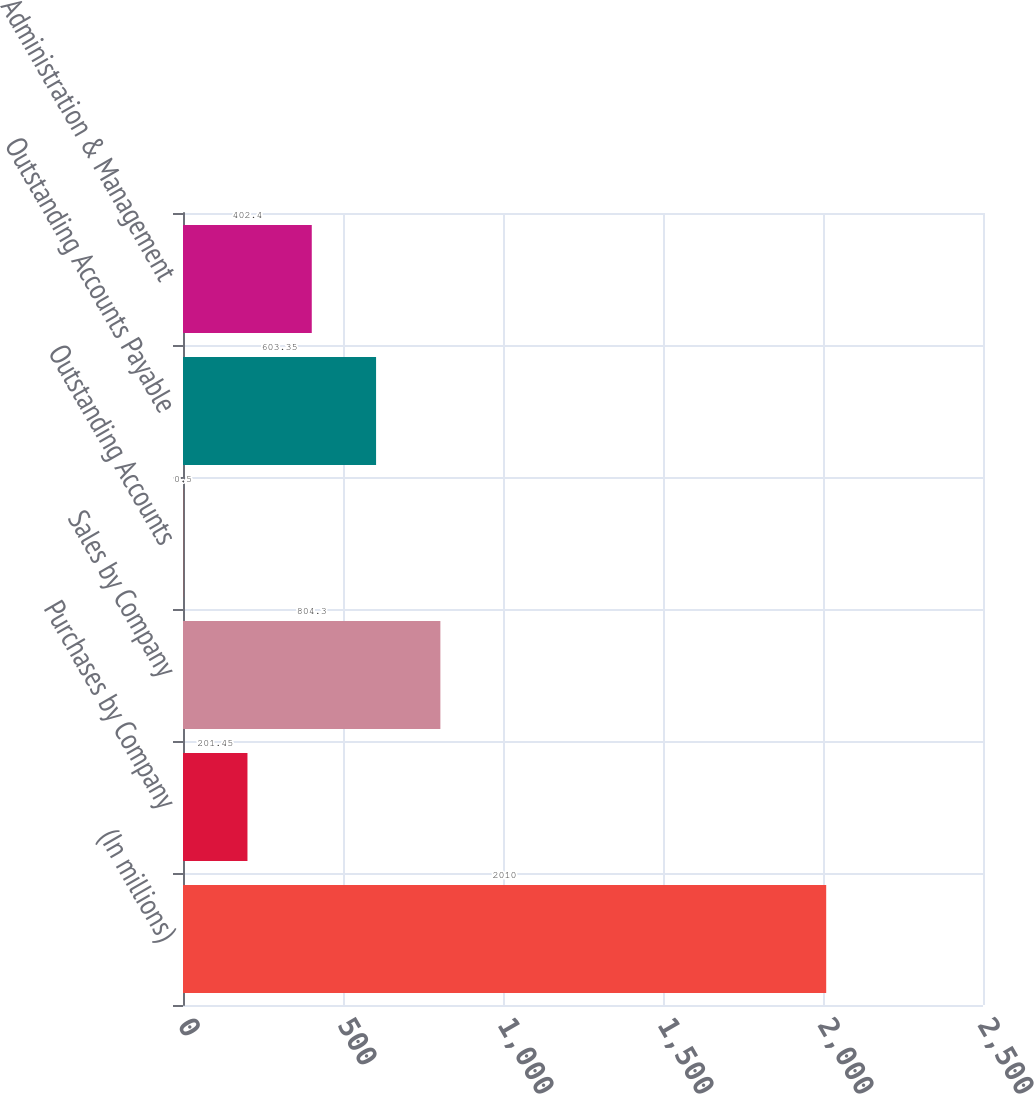Convert chart. <chart><loc_0><loc_0><loc_500><loc_500><bar_chart><fcel>(In millions)<fcel>Purchases by Company<fcel>Sales by Company<fcel>Outstanding Accounts<fcel>Outstanding Accounts Payable<fcel>Administration & Management<nl><fcel>2010<fcel>201.45<fcel>804.3<fcel>0.5<fcel>603.35<fcel>402.4<nl></chart> 